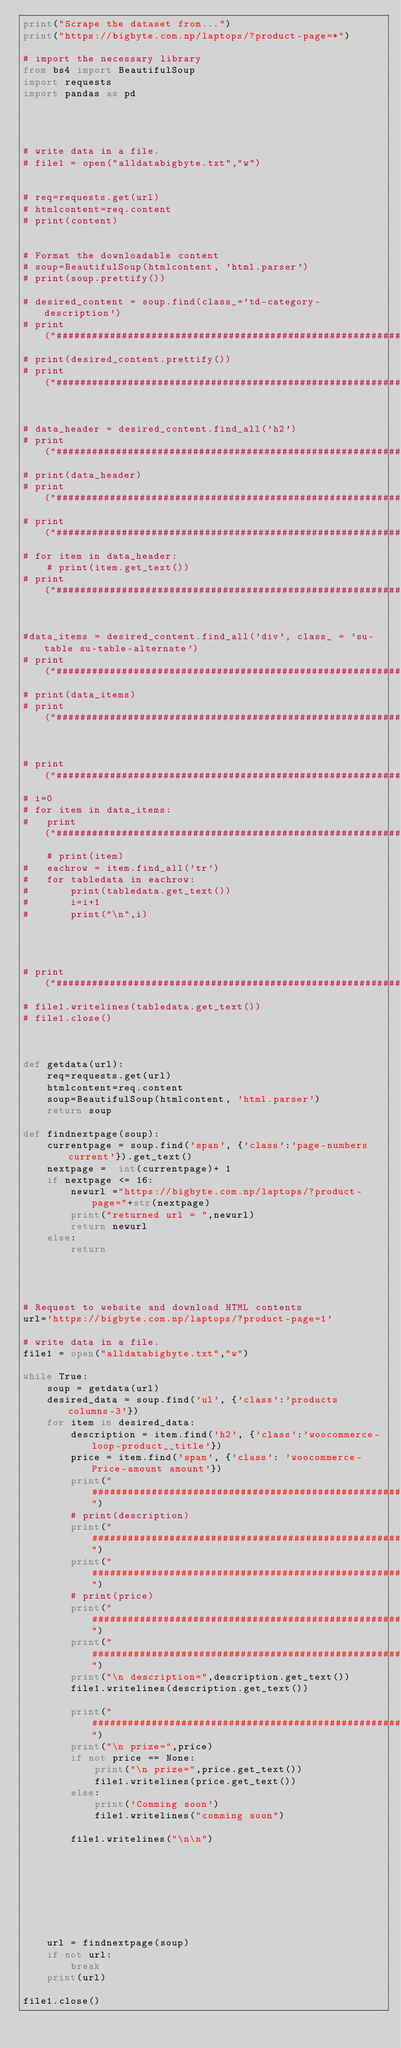Convert code to text. <code><loc_0><loc_0><loc_500><loc_500><_Python_>print("Scrape the dataset from...")
print("https://bigbyte.com.np/laptops/?product-page=*")

# import the necessary library 
from bs4 import BeautifulSoup
import requests
import pandas as pd




# write data in a file.
# file1 = open("alldatabigbyte.txt","w")


# req=requests.get(url)
# htmlcontent=req.content
# print(content)


# Format the downloadable content
# soup=BeautifulSoup(htmlcontent, 'html.parser')
# print(soup.prettify())

# desired_content = soup.find(class_='td-category-description')
# print("############################################################")
# print(desired_content.prettify())
# print("############################################################")


# data_header = desired_content.find_all('h2')
# print("############################################################")
# print(data_header)
# print("############################################################")
# print("############################################################")
# for item in data_header:
	# print(item.get_text())
# print("############################################################")


#data_items = desired_content.find_all('div', class_ = 'su-table su-table-alternate')
# print("############################################################")
# print(data_items)
# print("############################################################")


# print("############################################################")
# i=0
# for item in data_items:
# 	print("############################################################")
	# print(item)
#	eachrow = item.find_all('tr')
#	for tabledata in eachrow:
#		print(tabledata.get_text())
#		i=i+1
#		print("\n",i)




# print("############################################################")
# file1.writelines(tabledata.get_text())
# file1.close()



def getdata(url):
	req=requests.get(url)
	htmlcontent=req.content
	soup=BeautifulSoup(htmlcontent, 'html.parser')
	return soup

def findnextpage(soup):
	currentpage = soup.find('span', {'class':'page-numbers current'}).get_text()
	nextpage =  int(currentpage)+ 1
	if nextpage <= 16:
		newurl ="https://bigbyte.com.np/laptops/?product-page="+str(nextpage) 
		print("returned url = ",newurl)
		return newurl
	else:
		return




# Request to website and download HTML contents
url='https://bigbyte.com.np/laptops/?product-page=1'

# write data in a file.
file1 = open("alldatabigbyte.txt","w")

while True:
	soup = getdata(url)
	desired_data = soup.find('ul', {'class':'products columns-3'})
	for item in desired_data:
		description = item.find('h2', {'class':'woocommerce-loop-product__title'})
		price = item.find('span', {'class': 'woocommerce-Price-amount amount'})
		print("############################################################")
		# print(description)
		print("############################################################")
		print("############################################################")
		# print(price)
		print("############################################################")
		print("############################################################")
		print("\n description=",description.get_text())
		file1.writelines(description.get_text())

		print("############################################################")
		print("\n prize=",price)
		if not price == None:
			print("\n prize=",price.get_text())	
			file1.writelines(price.get_text())
		else:
			print('Comming soon')
			file1.writelines("comming soon")
			
		file1.writelines("\n\n")
			
		
	
	
	
	
	
	
	url = findnextpage(soup)
	if not url:
		break
	print(url)
	
file1.close()
	








</code> 